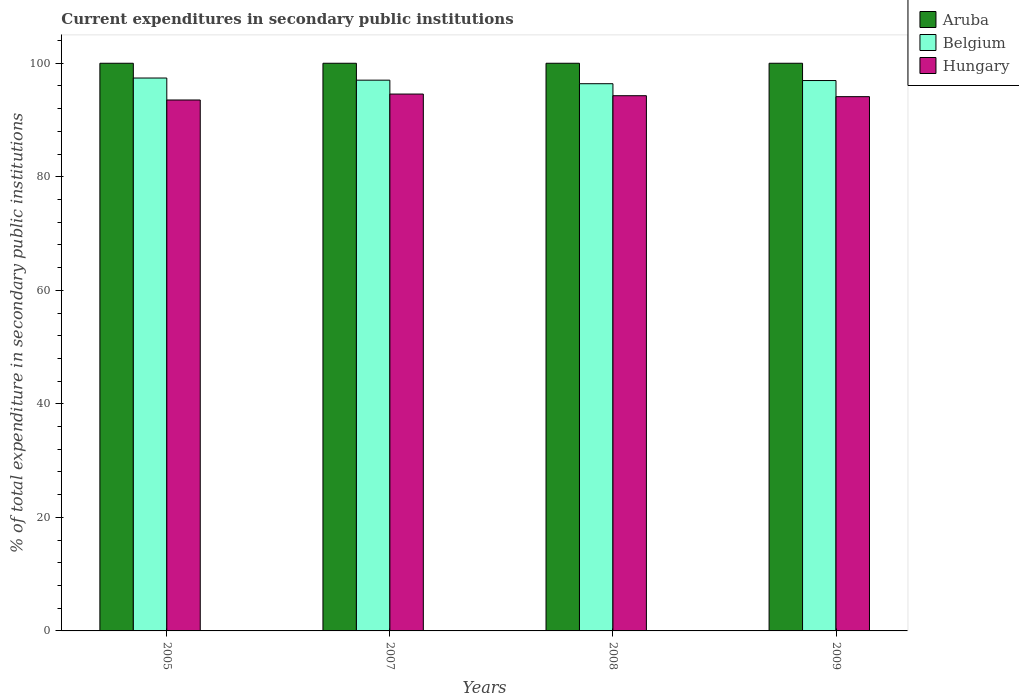How many groups of bars are there?
Provide a succinct answer. 4. Are the number of bars per tick equal to the number of legend labels?
Your response must be concise. Yes. Are the number of bars on each tick of the X-axis equal?
Your response must be concise. Yes. How many bars are there on the 1st tick from the left?
Provide a short and direct response. 3. What is the label of the 1st group of bars from the left?
Provide a succinct answer. 2005. What is the current expenditures in secondary public institutions in Hungary in 2007?
Ensure brevity in your answer.  94.57. Across all years, what is the maximum current expenditures in secondary public institutions in Belgium?
Ensure brevity in your answer.  97.4. Across all years, what is the minimum current expenditures in secondary public institutions in Hungary?
Provide a short and direct response. 93.53. What is the total current expenditures in secondary public institutions in Hungary in the graph?
Your answer should be very brief. 376.5. What is the difference between the current expenditures in secondary public institutions in Belgium in 2005 and that in 2009?
Provide a short and direct response. 0.44. What is the difference between the current expenditures in secondary public institutions in Hungary in 2007 and the current expenditures in secondary public institutions in Aruba in 2009?
Your answer should be compact. -5.43. In the year 2009, what is the difference between the current expenditures in secondary public institutions in Hungary and current expenditures in secondary public institutions in Aruba?
Give a very brief answer. -5.88. What is the ratio of the current expenditures in secondary public institutions in Hungary in 2007 to that in 2009?
Give a very brief answer. 1. Is the current expenditures in secondary public institutions in Hungary in 2005 less than that in 2008?
Make the answer very short. Yes. What is the difference between the highest and the second highest current expenditures in secondary public institutions in Belgium?
Keep it short and to the point. 0.38. What is the difference between the highest and the lowest current expenditures in secondary public institutions in Hungary?
Your response must be concise. 1.04. In how many years, is the current expenditures in secondary public institutions in Hungary greater than the average current expenditures in secondary public institutions in Hungary taken over all years?
Keep it short and to the point. 2. What does the 1st bar from the left in 2009 represents?
Give a very brief answer. Aruba. What does the 3rd bar from the right in 2008 represents?
Keep it short and to the point. Aruba. How many years are there in the graph?
Provide a succinct answer. 4. What is the difference between two consecutive major ticks on the Y-axis?
Your answer should be very brief. 20. Does the graph contain grids?
Your answer should be very brief. No. Where does the legend appear in the graph?
Your answer should be compact. Top right. How many legend labels are there?
Offer a terse response. 3. How are the legend labels stacked?
Keep it short and to the point. Vertical. What is the title of the graph?
Give a very brief answer. Current expenditures in secondary public institutions. What is the label or title of the X-axis?
Offer a terse response. Years. What is the label or title of the Y-axis?
Keep it short and to the point. % of total expenditure in secondary public institutions. What is the % of total expenditure in secondary public institutions in Aruba in 2005?
Make the answer very short. 100. What is the % of total expenditure in secondary public institutions of Belgium in 2005?
Ensure brevity in your answer.  97.4. What is the % of total expenditure in secondary public institutions of Hungary in 2005?
Ensure brevity in your answer.  93.53. What is the % of total expenditure in secondary public institutions in Aruba in 2007?
Offer a terse response. 100. What is the % of total expenditure in secondary public institutions in Belgium in 2007?
Keep it short and to the point. 97.02. What is the % of total expenditure in secondary public institutions of Hungary in 2007?
Offer a terse response. 94.57. What is the % of total expenditure in secondary public institutions of Belgium in 2008?
Your answer should be compact. 96.4. What is the % of total expenditure in secondary public institutions in Hungary in 2008?
Your response must be concise. 94.28. What is the % of total expenditure in secondary public institutions of Belgium in 2009?
Give a very brief answer. 96.96. What is the % of total expenditure in secondary public institutions of Hungary in 2009?
Offer a terse response. 94.12. Across all years, what is the maximum % of total expenditure in secondary public institutions of Aruba?
Your answer should be compact. 100. Across all years, what is the maximum % of total expenditure in secondary public institutions in Belgium?
Your answer should be compact. 97.4. Across all years, what is the maximum % of total expenditure in secondary public institutions of Hungary?
Your response must be concise. 94.57. Across all years, what is the minimum % of total expenditure in secondary public institutions of Belgium?
Give a very brief answer. 96.4. Across all years, what is the minimum % of total expenditure in secondary public institutions in Hungary?
Your response must be concise. 93.53. What is the total % of total expenditure in secondary public institutions of Belgium in the graph?
Offer a very short reply. 387.78. What is the total % of total expenditure in secondary public institutions in Hungary in the graph?
Give a very brief answer. 376.5. What is the difference between the % of total expenditure in secondary public institutions of Belgium in 2005 and that in 2007?
Give a very brief answer. 0.38. What is the difference between the % of total expenditure in secondary public institutions of Hungary in 2005 and that in 2007?
Your response must be concise. -1.04. What is the difference between the % of total expenditure in secondary public institutions of Aruba in 2005 and that in 2008?
Provide a succinct answer. 0. What is the difference between the % of total expenditure in secondary public institutions in Hungary in 2005 and that in 2008?
Offer a terse response. -0.76. What is the difference between the % of total expenditure in secondary public institutions of Aruba in 2005 and that in 2009?
Make the answer very short. 0. What is the difference between the % of total expenditure in secondary public institutions of Belgium in 2005 and that in 2009?
Offer a very short reply. 0.44. What is the difference between the % of total expenditure in secondary public institutions of Hungary in 2005 and that in 2009?
Your answer should be compact. -0.59. What is the difference between the % of total expenditure in secondary public institutions of Belgium in 2007 and that in 2008?
Your response must be concise. 0.62. What is the difference between the % of total expenditure in secondary public institutions in Hungary in 2007 and that in 2008?
Offer a terse response. 0.29. What is the difference between the % of total expenditure in secondary public institutions of Aruba in 2007 and that in 2009?
Ensure brevity in your answer.  0. What is the difference between the % of total expenditure in secondary public institutions in Belgium in 2007 and that in 2009?
Provide a succinct answer. 0.07. What is the difference between the % of total expenditure in secondary public institutions in Hungary in 2007 and that in 2009?
Ensure brevity in your answer.  0.46. What is the difference between the % of total expenditure in secondary public institutions of Belgium in 2008 and that in 2009?
Keep it short and to the point. -0.56. What is the difference between the % of total expenditure in secondary public institutions in Hungary in 2008 and that in 2009?
Make the answer very short. 0.17. What is the difference between the % of total expenditure in secondary public institutions in Aruba in 2005 and the % of total expenditure in secondary public institutions in Belgium in 2007?
Provide a short and direct response. 2.98. What is the difference between the % of total expenditure in secondary public institutions of Aruba in 2005 and the % of total expenditure in secondary public institutions of Hungary in 2007?
Ensure brevity in your answer.  5.43. What is the difference between the % of total expenditure in secondary public institutions in Belgium in 2005 and the % of total expenditure in secondary public institutions in Hungary in 2007?
Provide a short and direct response. 2.83. What is the difference between the % of total expenditure in secondary public institutions of Aruba in 2005 and the % of total expenditure in secondary public institutions of Belgium in 2008?
Offer a terse response. 3.6. What is the difference between the % of total expenditure in secondary public institutions in Aruba in 2005 and the % of total expenditure in secondary public institutions in Hungary in 2008?
Offer a terse response. 5.72. What is the difference between the % of total expenditure in secondary public institutions of Belgium in 2005 and the % of total expenditure in secondary public institutions of Hungary in 2008?
Provide a short and direct response. 3.11. What is the difference between the % of total expenditure in secondary public institutions in Aruba in 2005 and the % of total expenditure in secondary public institutions in Belgium in 2009?
Provide a short and direct response. 3.04. What is the difference between the % of total expenditure in secondary public institutions in Aruba in 2005 and the % of total expenditure in secondary public institutions in Hungary in 2009?
Provide a succinct answer. 5.88. What is the difference between the % of total expenditure in secondary public institutions of Belgium in 2005 and the % of total expenditure in secondary public institutions of Hungary in 2009?
Provide a succinct answer. 3.28. What is the difference between the % of total expenditure in secondary public institutions of Aruba in 2007 and the % of total expenditure in secondary public institutions of Belgium in 2008?
Your answer should be very brief. 3.6. What is the difference between the % of total expenditure in secondary public institutions of Aruba in 2007 and the % of total expenditure in secondary public institutions of Hungary in 2008?
Provide a succinct answer. 5.72. What is the difference between the % of total expenditure in secondary public institutions of Belgium in 2007 and the % of total expenditure in secondary public institutions of Hungary in 2008?
Your response must be concise. 2.74. What is the difference between the % of total expenditure in secondary public institutions of Aruba in 2007 and the % of total expenditure in secondary public institutions of Belgium in 2009?
Your answer should be very brief. 3.04. What is the difference between the % of total expenditure in secondary public institutions in Aruba in 2007 and the % of total expenditure in secondary public institutions in Hungary in 2009?
Provide a short and direct response. 5.88. What is the difference between the % of total expenditure in secondary public institutions in Belgium in 2007 and the % of total expenditure in secondary public institutions in Hungary in 2009?
Your answer should be compact. 2.91. What is the difference between the % of total expenditure in secondary public institutions of Aruba in 2008 and the % of total expenditure in secondary public institutions of Belgium in 2009?
Offer a very short reply. 3.04. What is the difference between the % of total expenditure in secondary public institutions of Aruba in 2008 and the % of total expenditure in secondary public institutions of Hungary in 2009?
Make the answer very short. 5.88. What is the difference between the % of total expenditure in secondary public institutions in Belgium in 2008 and the % of total expenditure in secondary public institutions in Hungary in 2009?
Keep it short and to the point. 2.28. What is the average % of total expenditure in secondary public institutions of Aruba per year?
Your response must be concise. 100. What is the average % of total expenditure in secondary public institutions of Belgium per year?
Your response must be concise. 96.94. What is the average % of total expenditure in secondary public institutions in Hungary per year?
Offer a terse response. 94.13. In the year 2005, what is the difference between the % of total expenditure in secondary public institutions of Aruba and % of total expenditure in secondary public institutions of Belgium?
Your answer should be compact. 2.6. In the year 2005, what is the difference between the % of total expenditure in secondary public institutions of Aruba and % of total expenditure in secondary public institutions of Hungary?
Give a very brief answer. 6.47. In the year 2005, what is the difference between the % of total expenditure in secondary public institutions of Belgium and % of total expenditure in secondary public institutions of Hungary?
Your response must be concise. 3.87. In the year 2007, what is the difference between the % of total expenditure in secondary public institutions of Aruba and % of total expenditure in secondary public institutions of Belgium?
Your answer should be very brief. 2.98. In the year 2007, what is the difference between the % of total expenditure in secondary public institutions in Aruba and % of total expenditure in secondary public institutions in Hungary?
Provide a short and direct response. 5.43. In the year 2007, what is the difference between the % of total expenditure in secondary public institutions in Belgium and % of total expenditure in secondary public institutions in Hungary?
Keep it short and to the point. 2.45. In the year 2008, what is the difference between the % of total expenditure in secondary public institutions in Aruba and % of total expenditure in secondary public institutions in Belgium?
Provide a short and direct response. 3.6. In the year 2008, what is the difference between the % of total expenditure in secondary public institutions of Aruba and % of total expenditure in secondary public institutions of Hungary?
Provide a succinct answer. 5.72. In the year 2008, what is the difference between the % of total expenditure in secondary public institutions of Belgium and % of total expenditure in secondary public institutions of Hungary?
Offer a terse response. 2.11. In the year 2009, what is the difference between the % of total expenditure in secondary public institutions in Aruba and % of total expenditure in secondary public institutions in Belgium?
Offer a very short reply. 3.04. In the year 2009, what is the difference between the % of total expenditure in secondary public institutions in Aruba and % of total expenditure in secondary public institutions in Hungary?
Your answer should be very brief. 5.88. In the year 2009, what is the difference between the % of total expenditure in secondary public institutions in Belgium and % of total expenditure in secondary public institutions in Hungary?
Provide a succinct answer. 2.84. What is the ratio of the % of total expenditure in secondary public institutions of Aruba in 2005 to that in 2007?
Offer a terse response. 1. What is the ratio of the % of total expenditure in secondary public institutions in Belgium in 2005 to that in 2008?
Give a very brief answer. 1.01. What is the ratio of the % of total expenditure in secondary public institutions of Belgium in 2005 to that in 2009?
Make the answer very short. 1. What is the ratio of the % of total expenditure in secondary public institutions in Hungary in 2005 to that in 2009?
Provide a succinct answer. 0.99. What is the ratio of the % of total expenditure in secondary public institutions in Aruba in 2007 to that in 2009?
Provide a short and direct response. 1. What is the ratio of the % of total expenditure in secondary public institutions in Hungary in 2007 to that in 2009?
Provide a short and direct response. 1. What is the ratio of the % of total expenditure in secondary public institutions of Belgium in 2008 to that in 2009?
Offer a terse response. 0.99. What is the ratio of the % of total expenditure in secondary public institutions in Hungary in 2008 to that in 2009?
Keep it short and to the point. 1. What is the difference between the highest and the second highest % of total expenditure in secondary public institutions of Aruba?
Provide a short and direct response. 0. What is the difference between the highest and the second highest % of total expenditure in secondary public institutions in Belgium?
Provide a succinct answer. 0.38. What is the difference between the highest and the second highest % of total expenditure in secondary public institutions in Hungary?
Offer a terse response. 0.29. What is the difference between the highest and the lowest % of total expenditure in secondary public institutions of Aruba?
Give a very brief answer. 0. What is the difference between the highest and the lowest % of total expenditure in secondary public institutions of Hungary?
Give a very brief answer. 1.04. 